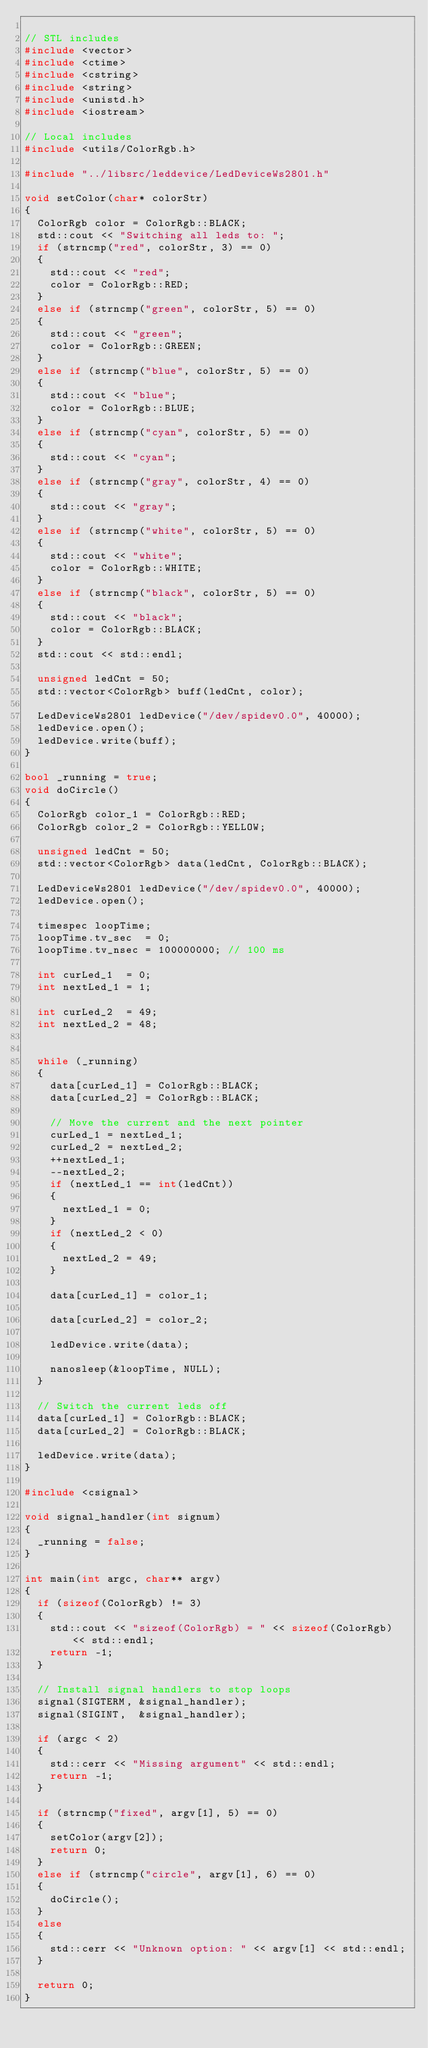<code> <loc_0><loc_0><loc_500><loc_500><_C++_>
// STL includes
#include <vector>
#include <ctime>
#include <cstring>
#include <string>
#include <unistd.h>
#include <iostream>

// Local includes
#include <utils/ColorRgb.h>

#include "../libsrc/leddevice/LedDeviceWs2801.h"

void setColor(char* colorStr)
{
	ColorRgb color = ColorRgb::BLACK;
	std::cout << "Switching all leds to: ";
	if (strncmp("red", colorStr, 3) == 0)
	{
		std::cout << "red";
		color = ColorRgb::RED;
	}
	else if (strncmp("green", colorStr, 5) == 0)
	{
		std::cout << "green";
		color = ColorRgb::GREEN;
	}
	else if (strncmp("blue", colorStr, 5) == 0)
	{
		std::cout << "blue";
		color = ColorRgb::BLUE;
	}
	else if (strncmp("cyan", colorStr, 5) == 0)
	{
		std::cout << "cyan";
	}
	else if (strncmp("gray", colorStr, 4) == 0)
	{
		std::cout << "gray";
	}
	else if (strncmp("white", colorStr, 5) == 0)
	{
		std::cout << "white";
		color = ColorRgb::WHITE;
	}
	else if (strncmp("black", colorStr, 5) == 0)
	{
		std::cout << "black";
		color = ColorRgb::BLACK;
	}
	std::cout << std::endl;

	unsigned ledCnt = 50;
	std::vector<ColorRgb> buff(ledCnt, color);

	LedDeviceWs2801 ledDevice("/dev/spidev0.0", 40000);
	ledDevice.open();
	ledDevice.write(buff);
}

bool _running = true;
void doCircle()
{
	ColorRgb color_1 = ColorRgb::RED;
	ColorRgb color_2 = ColorRgb::YELLOW;

	unsigned ledCnt = 50;
	std::vector<ColorRgb> data(ledCnt, ColorRgb::BLACK);

	LedDeviceWs2801 ledDevice("/dev/spidev0.0", 40000);
	ledDevice.open();

	timespec loopTime;
	loopTime.tv_sec  = 0;
	loopTime.tv_nsec = 100000000; // 100 ms

	int curLed_1  = 0;
	int nextLed_1 = 1;

	int curLed_2  = 49;
	int nextLed_2 = 48;


	while (_running)
	{
		data[curLed_1] = ColorRgb::BLACK;
		data[curLed_2] = ColorRgb::BLACK;

		// Move the current and the next pointer
		curLed_1 = nextLed_1;
		curLed_2 = nextLed_2;
		++nextLed_1;
		--nextLed_2;
		if (nextLed_1 == int(ledCnt))
		{
			nextLed_1 = 0;
		}
		if (nextLed_2 < 0)
		{
			nextLed_2 = 49;
		}

		data[curLed_1] = color_1;

		data[curLed_2] = color_2;

		ledDevice.write(data);

		nanosleep(&loopTime, NULL);
	}

	// Switch the current leds off
	data[curLed_1] = ColorRgb::BLACK;
	data[curLed_2] = ColorRgb::BLACK;

	ledDevice.write(data);
}

#include <csignal>

void signal_handler(int signum)
{
	_running = false;
}

int main(int argc, char** argv)
{
	if (sizeof(ColorRgb) != 3)
	{
		std::cout << "sizeof(ColorRgb) = " << sizeof(ColorRgb) << std::endl;
		return -1;
	}

	// Install signal handlers to stop loops
	signal(SIGTERM, &signal_handler);
	signal(SIGINT,  &signal_handler);

	if (argc < 2)
	{
		std::cerr << "Missing argument" << std::endl;
		return -1;
	}

	if (strncmp("fixed", argv[1], 5) == 0)
	{
		setColor(argv[2]);
		return 0;
	}
	else if (strncmp("circle", argv[1], 6) == 0)
	{
		doCircle();
	}
	else
	{
		std::cerr << "Unknown option: " << argv[1] << std::endl;
	}

	return 0;
}

</code> 